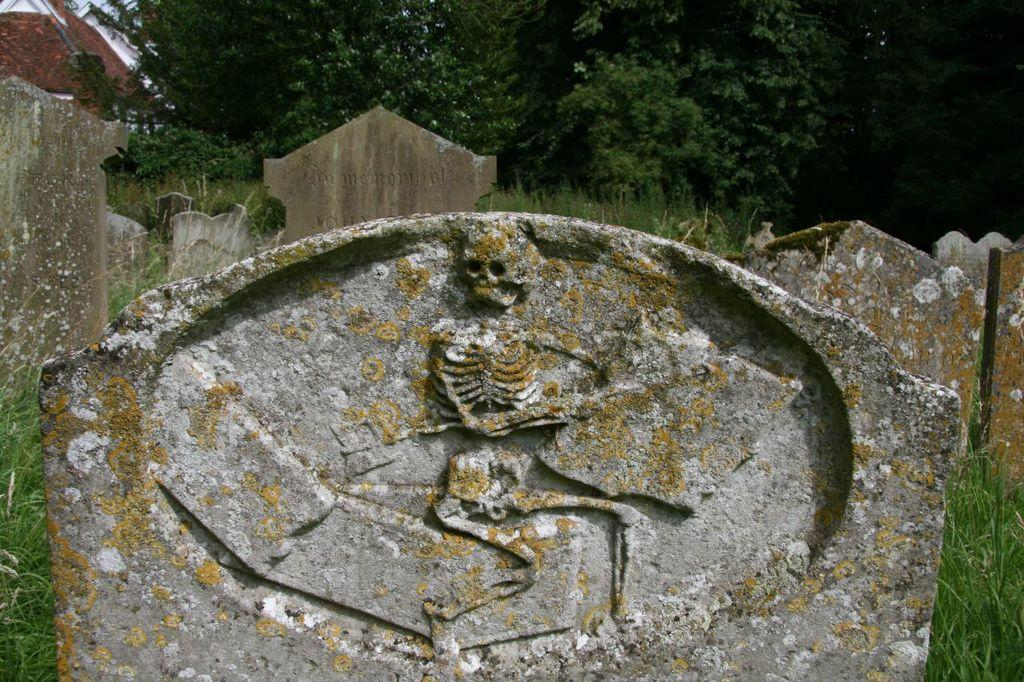What type of objects can be seen in the foreground of the picture? There are grave stones in the picture. What can be seen in the background of the picture? There are trees and grass visible in the background of the picture. Are there any other objects present in the background of the picture? Yes, there are other unspecified objects in the background of the picture. How many legs can be seen on the crate in the picture? There is no crate present in the picture, so it is not possible to determine the number of legs on a crate. 